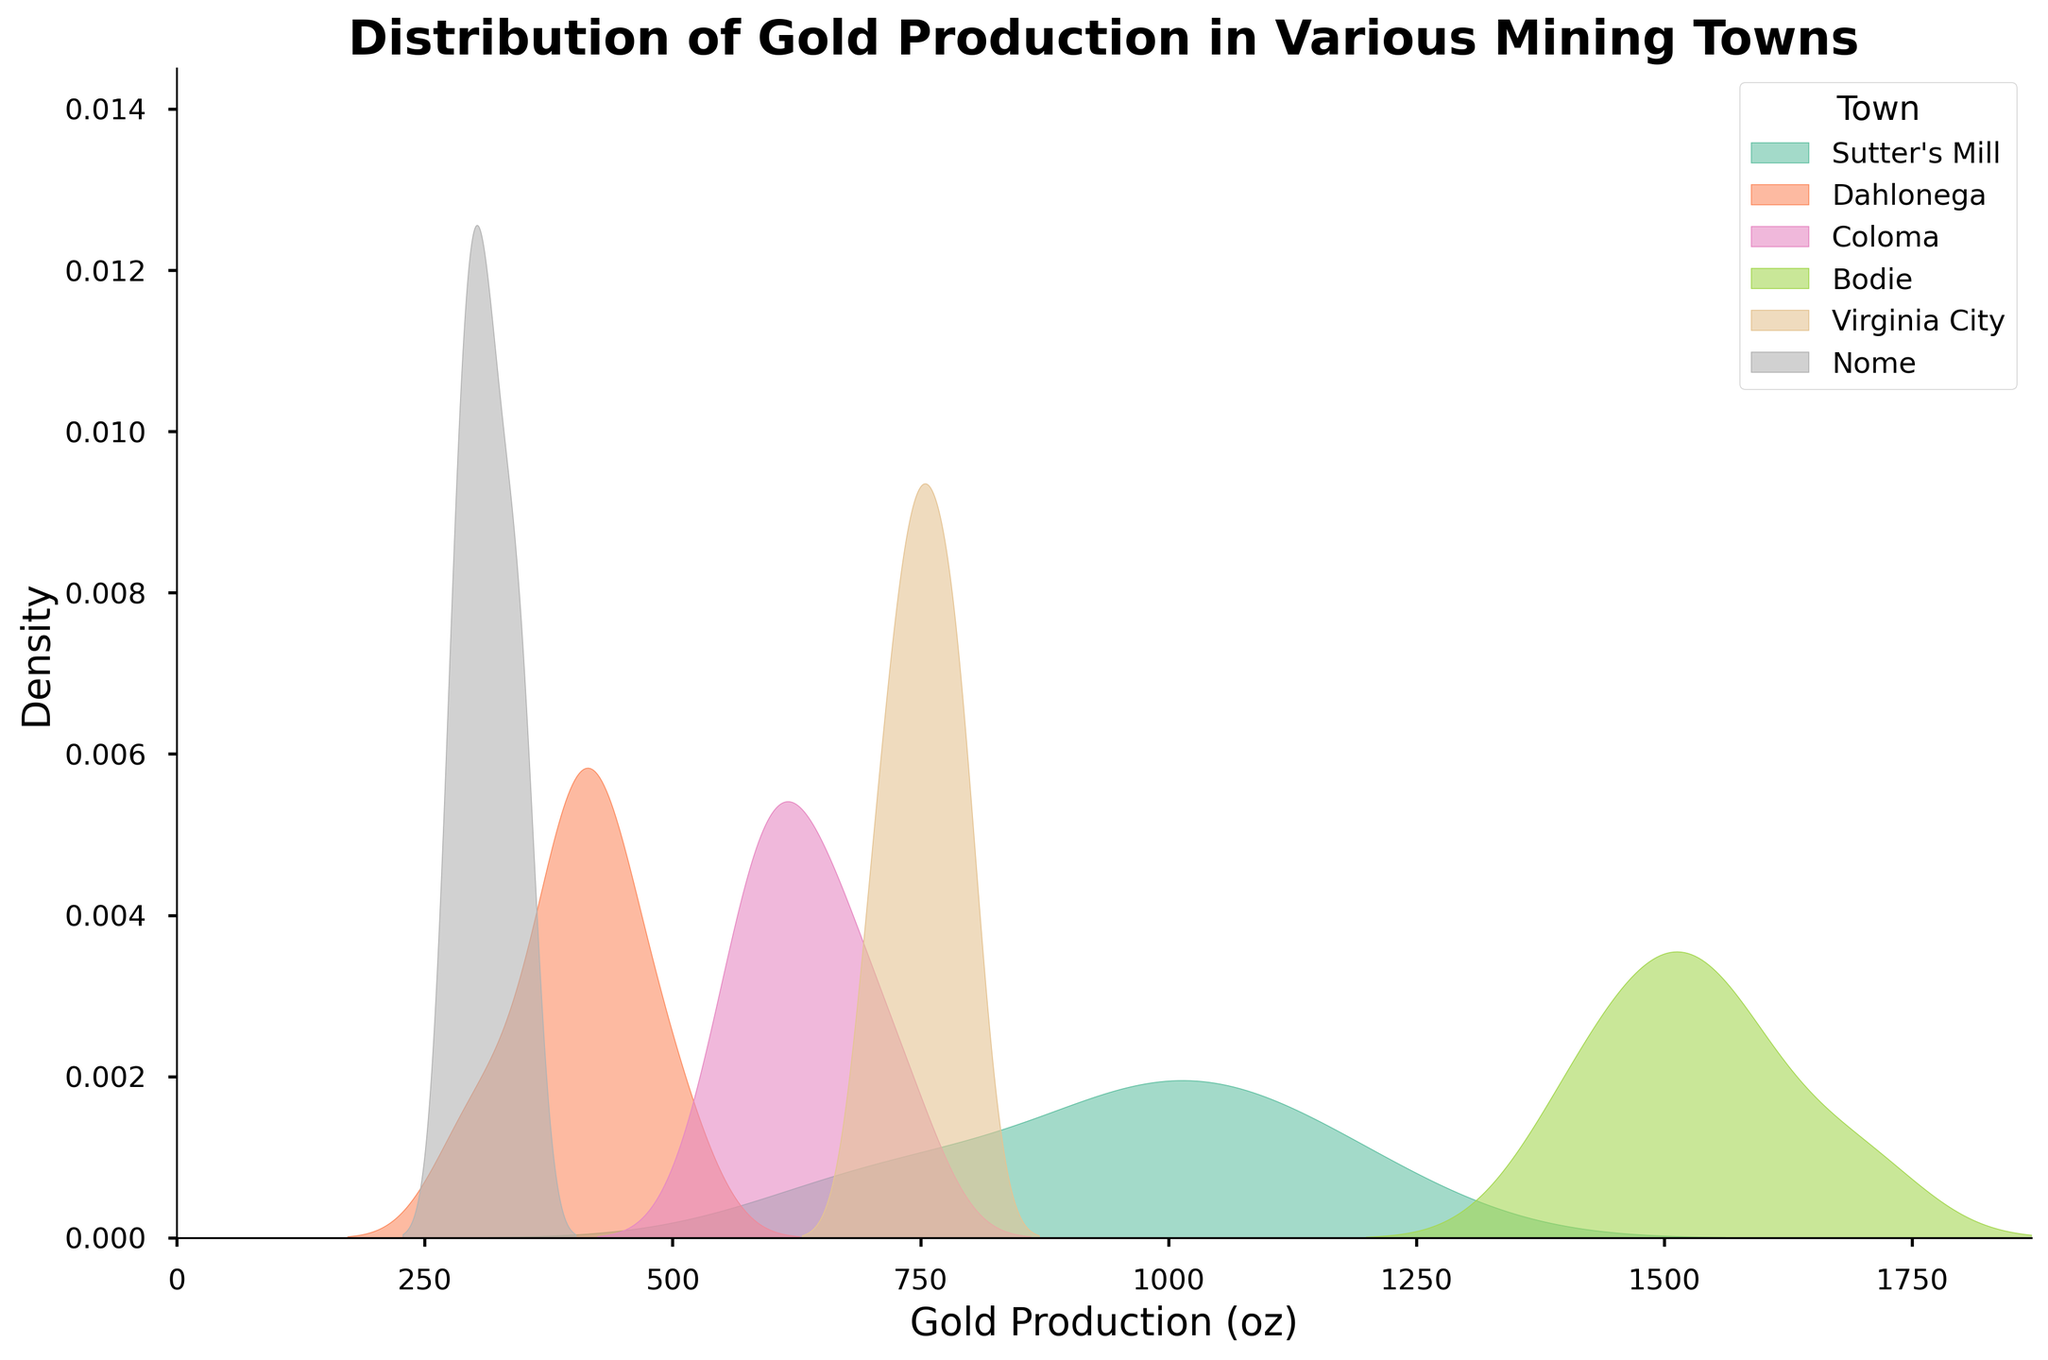What's the title of the figure? The title of the figure is provided at the top of the plot. It is set in a bold, large font to make it easily identifiable.
Answer: Distribution of Gold Production in Various Mining Towns Which town has the highest gold production peak in the density plot? By observing the density curves, the peak represents where the density is the highest. The town with the highest peak can be identified by the curve that reaches the greatest y-value.
Answer: Bodie What is the range of the x-axis? The x-axis represents gold production amounts and the range can be determined from the plot's horizontal bounds. The leftmost part of the axis starts at 0 and extends to a value slightly higher than the maximum production amount in the data, which is 1700.
Answer: 0 to approximately 1870 How does the gold production distribution in Sutter's Mill compare to Dahlonega? Comparing the density plots of both towns, one can see the differences in shape and spread. Sutter's Mill has a wider range and a higher peak compared to Dahlonega, indicating a higher and more varied production amount.
Answer: Sutter's Mill has higher and more varied production Which town has the narrowest distribution of gold production amounts? A narrower distribution indicates that the gold production amounts are closely clustered around a central value. This can be seen by the density curve being taller and more peaked rather than spread out.
Answer: Dahlonega How many distinct towns are represented in the plot? Each density plot is labeled with the name of the town it represents. Counting these labeled curves gives the total number of distinct towns.
Answer: 6 Are there any towns with overlapping density plots, and what does it indicate? Overlapping density plots indicate that the gold production amounts for those towns fall within a similar range. This can be observed visually by noting where the curves intersect or cover the same horizontal region.
Answer: Yes, it indicates similar gold production amounts Which town has the most spread-out (widest) distribution of gold production? The width of the distribution can be determined by observing the horizontal span of the density curve. A wider span suggests a more spread-out distribution.
Answer: Bodie What is the approximate peak density value for Coloma? The peak density value is the highest point on the density curve for Coloma. By observing the vertical axis and where the peak of Coloma's curve lies, one can approximate this value.
Answer: Approximately 0.0042 